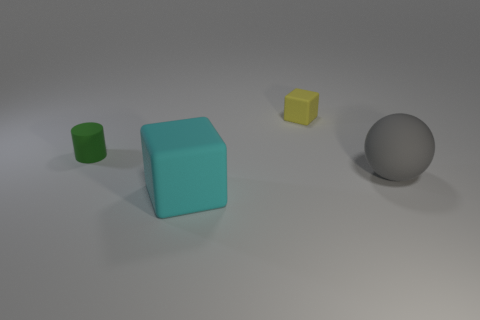There is a thing behind the small green cylinder; what is its shape? cube 